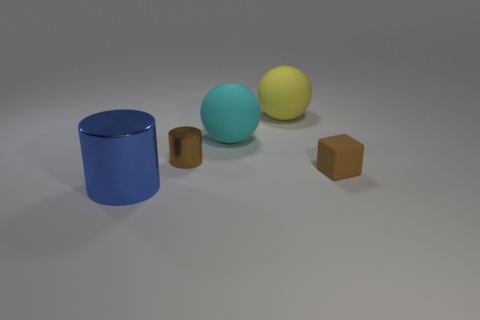Add 3 big shiny cylinders. How many objects exist? 8 Subtract all cubes. How many objects are left? 4 Add 5 tiny yellow objects. How many tiny yellow objects exist? 5 Subtract 0 cyan cylinders. How many objects are left? 5 Subtract all matte things. Subtract all brown metal cylinders. How many objects are left? 1 Add 3 cyan balls. How many cyan balls are left? 4 